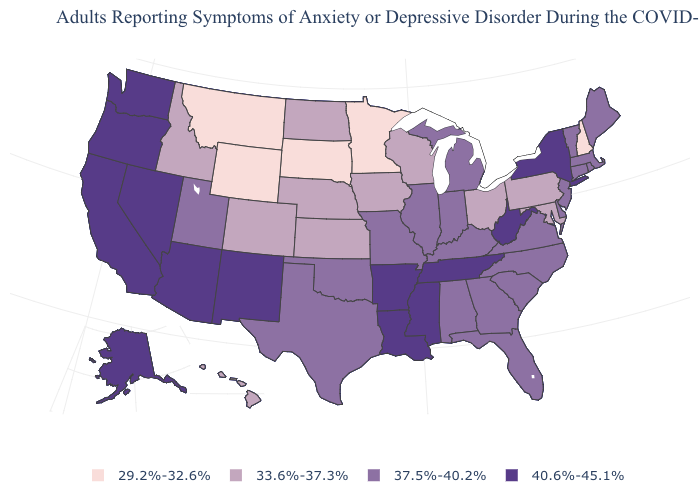Does West Virginia have a lower value than Kansas?
Write a very short answer. No. What is the value of Louisiana?
Write a very short answer. 40.6%-45.1%. What is the value of Washington?
Answer briefly. 40.6%-45.1%. What is the highest value in the MidWest ?
Short answer required. 37.5%-40.2%. What is the value of Vermont?
Quick response, please. 37.5%-40.2%. What is the value of Kansas?
Answer briefly. 33.6%-37.3%. Name the states that have a value in the range 29.2%-32.6%?
Give a very brief answer. Minnesota, Montana, New Hampshire, South Dakota, Wyoming. How many symbols are there in the legend?
Keep it brief. 4. Does North Dakota have a higher value than Oklahoma?
Short answer required. No. Does the map have missing data?
Quick response, please. No. What is the value of Colorado?
Be succinct. 33.6%-37.3%. What is the value of Massachusetts?
Be succinct. 37.5%-40.2%. What is the highest value in the USA?
Concise answer only. 40.6%-45.1%. Is the legend a continuous bar?
Write a very short answer. No. Name the states that have a value in the range 29.2%-32.6%?
Quick response, please. Minnesota, Montana, New Hampshire, South Dakota, Wyoming. 